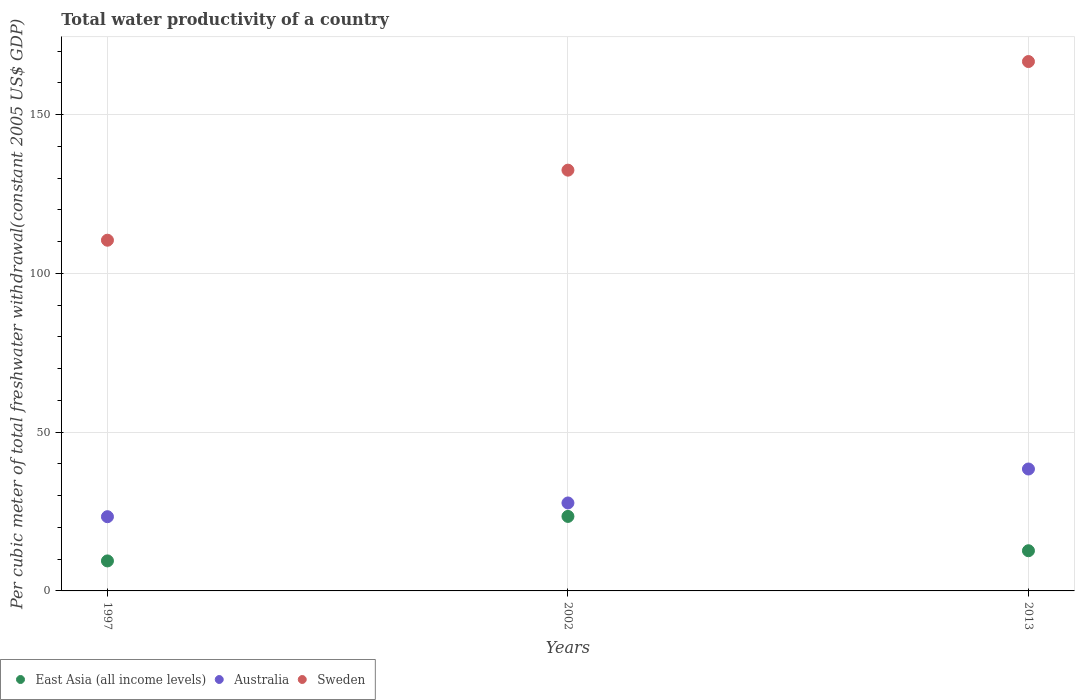What is the total water productivity in Australia in 2013?
Your answer should be very brief. 38.4. Across all years, what is the maximum total water productivity in Australia?
Offer a very short reply. 38.4. Across all years, what is the minimum total water productivity in Sweden?
Your response must be concise. 110.46. In which year was the total water productivity in East Asia (all income levels) maximum?
Your answer should be very brief. 2002. In which year was the total water productivity in East Asia (all income levels) minimum?
Offer a very short reply. 1997. What is the total total water productivity in Sweden in the graph?
Provide a succinct answer. 409.74. What is the difference between the total water productivity in Sweden in 1997 and that in 2013?
Keep it short and to the point. -56.28. What is the difference between the total water productivity in Australia in 2013 and the total water productivity in East Asia (all income levels) in 1997?
Provide a succinct answer. 28.95. What is the average total water productivity in Australia per year?
Your answer should be compact. 29.83. In the year 2013, what is the difference between the total water productivity in Sweden and total water productivity in Australia?
Provide a short and direct response. 128.34. In how many years, is the total water productivity in East Asia (all income levels) greater than 110 US$?
Provide a short and direct response. 0. What is the ratio of the total water productivity in East Asia (all income levels) in 2002 to that in 2013?
Make the answer very short. 1.85. Is the difference between the total water productivity in Sweden in 1997 and 2002 greater than the difference between the total water productivity in Australia in 1997 and 2002?
Provide a succinct answer. No. What is the difference between the highest and the second highest total water productivity in Sweden?
Provide a succinct answer. 34.21. What is the difference between the highest and the lowest total water productivity in Australia?
Offer a very short reply. 15.02. Is the total water productivity in Sweden strictly greater than the total water productivity in East Asia (all income levels) over the years?
Ensure brevity in your answer.  Yes. How many dotlines are there?
Provide a short and direct response. 3. What is the difference between two consecutive major ticks on the Y-axis?
Your answer should be very brief. 50. Are the values on the major ticks of Y-axis written in scientific E-notation?
Make the answer very short. No. Where does the legend appear in the graph?
Give a very brief answer. Bottom left. How many legend labels are there?
Give a very brief answer. 3. What is the title of the graph?
Your response must be concise. Total water productivity of a country. What is the label or title of the Y-axis?
Offer a very short reply. Per cubic meter of total freshwater withdrawal(constant 2005 US$ GDP). What is the Per cubic meter of total freshwater withdrawal(constant 2005 US$ GDP) of East Asia (all income levels) in 1997?
Your response must be concise. 9.45. What is the Per cubic meter of total freshwater withdrawal(constant 2005 US$ GDP) of Australia in 1997?
Provide a short and direct response. 23.38. What is the Per cubic meter of total freshwater withdrawal(constant 2005 US$ GDP) in Sweden in 1997?
Keep it short and to the point. 110.46. What is the Per cubic meter of total freshwater withdrawal(constant 2005 US$ GDP) of East Asia (all income levels) in 2002?
Provide a succinct answer. 23.47. What is the Per cubic meter of total freshwater withdrawal(constant 2005 US$ GDP) of Australia in 2002?
Your answer should be very brief. 27.7. What is the Per cubic meter of total freshwater withdrawal(constant 2005 US$ GDP) of Sweden in 2002?
Ensure brevity in your answer.  132.53. What is the Per cubic meter of total freshwater withdrawal(constant 2005 US$ GDP) of East Asia (all income levels) in 2013?
Give a very brief answer. 12.66. What is the Per cubic meter of total freshwater withdrawal(constant 2005 US$ GDP) in Australia in 2013?
Provide a succinct answer. 38.4. What is the Per cubic meter of total freshwater withdrawal(constant 2005 US$ GDP) of Sweden in 2013?
Ensure brevity in your answer.  166.74. Across all years, what is the maximum Per cubic meter of total freshwater withdrawal(constant 2005 US$ GDP) of East Asia (all income levels)?
Offer a terse response. 23.47. Across all years, what is the maximum Per cubic meter of total freshwater withdrawal(constant 2005 US$ GDP) of Australia?
Your response must be concise. 38.4. Across all years, what is the maximum Per cubic meter of total freshwater withdrawal(constant 2005 US$ GDP) of Sweden?
Ensure brevity in your answer.  166.74. Across all years, what is the minimum Per cubic meter of total freshwater withdrawal(constant 2005 US$ GDP) in East Asia (all income levels)?
Your answer should be very brief. 9.45. Across all years, what is the minimum Per cubic meter of total freshwater withdrawal(constant 2005 US$ GDP) of Australia?
Offer a terse response. 23.38. Across all years, what is the minimum Per cubic meter of total freshwater withdrawal(constant 2005 US$ GDP) in Sweden?
Provide a short and direct response. 110.46. What is the total Per cubic meter of total freshwater withdrawal(constant 2005 US$ GDP) of East Asia (all income levels) in the graph?
Make the answer very short. 45.58. What is the total Per cubic meter of total freshwater withdrawal(constant 2005 US$ GDP) of Australia in the graph?
Make the answer very short. 89.48. What is the total Per cubic meter of total freshwater withdrawal(constant 2005 US$ GDP) of Sweden in the graph?
Make the answer very short. 409.74. What is the difference between the Per cubic meter of total freshwater withdrawal(constant 2005 US$ GDP) of East Asia (all income levels) in 1997 and that in 2002?
Your answer should be compact. -14.02. What is the difference between the Per cubic meter of total freshwater withdrawal(constant 2005 US$ GDP) in Australia in 1997 and that in 2002?
Your answer should be compact. -4.33. What is the difference between the Per cubic meter of total freshwater withdrawal(constant 2005 US$ GDP) of Sweden in 1997 and that in 2002?
Give a very brief answer. -22.07. What is the difference between the Per cubic meter of total freshwater withdrawal(constant 2005 US$ GDP) in East Asia (all income levels) in 1997 and that in 2013?
Ensure brevity in your answer.  -3.21. What is the difference between the Per cubic meter of total freshwater withdrawal(constant 2005 US$ GDP) in Australia in 1997 and that in 2013?
Make the answer very short. -15.02. What is the difference between the Per cubic meter of total freshwater withdrawal(constant 2005 US$ GDP) in Sweden in 1997 and that in 2013?
Offer a terse response. -56.28. What is the difference between the Per cubic meter of total freshwater withdrawal(constant 2005 US$ GDP) in East Asia (all income levels) in 2002 and that in 2013?
Make the answer very short. 10.81. What is the difference between the Per cubic meter of total freshwater withdrawal(constant 2005 US$ GDP) of Australia in 2002 and that in 2013?
Provide a short and direct response. -10.7. What is the difference between the Per cubic meter of total freshwater withdrawal(constant 2005 US$ GDP) in Sweden in 2002 and that in 2013?
Give a very brief answer. -34.21. What is the difference between the Per cubic meter of total freshwater withdrawal(constant 2005 US$ GDP) in East Asia (all income levels) in 1997 and the Per cubic meter of total freshwater withdrawal(constant 2005 US$ GDP) in Australia in 2002?
Make the answer very short. -18.25. What is the difference between the Per cubic meter of total freshwater withdrawal(constant 2005 US$ GDP) in East Asia (all income levels) in 1997 and the Per cubic meter of total freshwater withdrawal(constant 2005 US$ GDP) in Sweden in 2002?
Offer a very short reply. -123.08. What is the difference between the Per cubic meter of total freshwater withdrawal(constant 2005 US$ GDP) in Australia in 1997 and the Per cubic meter of total freshwater withdrawal(constant 2005 US$ GDP) in Sweden in 2002?
Your answer should be very brief. -109.15. What is the difference between the Per cubic meter of total freshwater withdrawal(constant 2005 US$ GDP) of East Asia (all income levels) in 1997 and the Per cubic meter of total freshwater withdrawal(constant 2005 US$ GDP) of Australia in 2013?
Your response must be concise. -28.95. What is the difference between the Per cubic meter of total freshwater withdrawal(constant 2005 US$ GDP) in East Asia (all income levels) in 1997 and the Per cubic meter of total freshwater withdrawal(constant 2005 US$ GDP) in Sweden in 2013?
Your answer should be very brief. -157.29. What is the difference between the Per cubic meter of total freshwater withdrawal(constant 2005 US$ GDP) of Australia in 1997 and the Per cubic meter of total freshwater withdrawal(constant 2005 US$ GDP) of Sweden in 2013?
Provide a succinct answer. -143.36. What is the difference between the Per cubic meter of total freshwater withdrawal(constant 2005 US$ GDP) in East Asia (all income levels) in 2002 and the Per cubic meter of total freshwater withdrawal(constant 2005 US$ GDP) in Australia in 2013?
Your answer should be compact. -14.93. What is the difference between the Per cubic meter of total freshwater withdrawal(constant 2005 US$ GDP) of East Asia (all income levels) in 2002 and the Per cubic meter of total freshwater withdrawal(constant 2005 US$ GDP) of Sweden in 2013?
Provide a succinct answer. -143.27. What is the difference between the Per cubic meter of total freshwater withdrawal(constant 2005 US$ GDP) of Australia in 2002 and the Per cubic meter of total freshwater withdrawal(constant 2005 US$ GDP) of Sweden in 2013?
Your answer should be compact. -139.04. What is the average Per cubic meter of total freshwater withdrawal(constant 2005 US$ GDP) of East Asia (all income levels) per year?
Offer a terse response. 15.19. What is the average Per cubic meter of total freshwater withdrawal(constant 2005 US$ GDP) of Australia per year?
Provide a succinct answer. 29.83. What is the average Per cubic meter of total freshwater withdrawal(constant 2005 US$ GDP) of Sweden per year?
Your answer should be very brief. 136.58. In the year 1997, what is the difference between the Per cubic meter of total freshwater withdrawal(constant 2005 US$ GDP) of East Asia (all income levels) and Per cubic meter of total freshwater withdrawal(constant 2005 US$ GDP) of Australia?
Give a very brief answer. -13.93. In the year 1997, what is the difference between the Per cubic meter of total freshwater withdrawal(constant 2005 US$ GDP) in East Asia (all income levels) and Per cubic meter of total freshwater withdrawal(constant 2005 US$ GDP) in Sweden?
Offer a terse response. -101.01. In the year 1997, what is the difference between the Per cubic meter of total freshwater withdrawal(constant 2005 US$ GDP) in Australia and Per cubic meter of total freshwater withdrawal(constant 2005 US$ GDP) in Sweden?
Your answer should be compact. -87.09. In the year 2002, what is the difference between the Per cubic meter of total freshwater withdrawal(constant 2005 US$ GDP) in East Asia (all income levels) and Per cubic meter of total freshwater withdrawal(constant 2005 US$ GDP) in Australia?
Ensure brevity in your answer.  -4.24. In the year 2002, what is the difference between the Per cubic meter of total freshwater withdrawal(constant 2005 US$ GDP) in East Asia (all income levels) and Per cubic meter of total freshwater withdrawal(constant 2005 US$ GDP) in Sweden?
Make the answer very short. -109.06. In the year 2002, what is the difference between the Per cubic meter of total freshwater withdrawal(constant 2005 US$ GDP) of Australia and Per cubic meter of total freshwater withdrawal(constant 2005 US$ GDP) of Sweden?
Your response must be concise. -104.83. In the year 2013, what is the difference between the Per cubic meter of total freshwater withdrawal(constant 2005 US$ GDP) of East Asia (all income levels) and Per cubic meter of total freshwater withdrawal(constant 2005 US$ GDP) of Australia?
Your response must be concise. -25.74. In the year 2013, what is the difference between the Per cubic meter of total freshwater withdrawal(constant 2005 US$ GDP) of East Asia (all income levels) and Per cubic meter of total freshwater withdrawal(constant 2005 US$ GDP) of Sweden?
Keep it short and to the point. -154.08. In the year 2013, what is the difference between the Per cubic meter of total freshwater withdrawal(constant 2005 US$ GDP) in Australia and Per cubic meter of total freshwater withdrawal(constant 2005 US$ GDP) in Sweden?
Give a very brief answer. -128.34. What is the ratio of the Per cubic meter of total freshwater withdrawal(constant 2005 US$ GDP) of East Asia (all income levels) in 1997 to that in 2002?
Provide a succinct answer. 0.4. What is the ratio of the Per cubic meter of total freshwater withdrawal(constant 2005 US$ GDP) in Australia in 1997 to that in 2002?
Give a very brief answer. 0.84. What is the ratio of the Per cubic meter of total freshwater withdrawal(constant 2005 US$ GDP) in Sweden in 1997 to that in 2002?
Provide a succinct answer. 0.83. What is the ratio of the Per cubic meter of total freshwater withdrawal(constant 2005 US$ GDP) in East Asia (all income levels) in 1997 to that in 2013?
Make the answer very short. 0.75. What is the ratio of the Per cubic meter of total freshwater withdrawal(constant 2005 US$ GDP) in Australia in 1997 to that in 2013?
Provide a short and direct response. 0.61. What is the ratio of the Per cubic meter of total freshwater withdrawal(constant 2005 US$ GDP) of Sweden in 1997 to that in 2013?
Offer a terse response. 0.66. What is the ratio of the Per cubic meter of total freshwater withdrawal(constant 2005 US$ GDP) of East Asia (all income levels) in 2002 to that in 2013?
Provide a succinct answer. 1.85. What is the ratio of the Per cubic meter of total freshwater withdrawal(constant 2005 US$ GDP) in Australia in 2002 to that in 2013?
Your response must be concise. 0.72. What is the ratio of the Per cubic meter of total freshwater withdrawal(constant 2005 US$ GDP) of Sweden in 2002 to that in 2013?
Your answer should be very brief. 0.79. What is the difference between the highest and the second highest Per cubic meter of total freshwater withdrawal(constant 2005 US$ GDP) of East Asia (all income levels)?
Offer a very short reply. 10.81. What is the difference between the highest and the second highest Per cubic meter of total freshwater withdrawal(constant 2005 US$ GDP) in Australia?
Give a very brief answer. 10.7. What is the difference between the highest and the second highest Per cubic meter of total freshwater withdrawal(constant 2005 US$ GDP) of Sweden?
Keep it short and to the point. 34.21. What is the difference between the highest and the lowest Per cubic meter of total freshwater withdrawal(constant 2005 US$ GDP) in East Asia (all income levels)?
Your response must be concise. 14.02. What is the difference between the highest and the lowest Per cubic meter of total freshwater withdrawal(constant 2005 US$ GDP) in Australia?
Provide a short and direct response. 15.02. What is the difference between the highest and the lowest Per cubic meter of total freshwater withdrawal(constant 2005 US$ GDP) of Sweden?
Your answer should be compact. 56.28. 